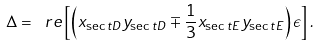Convert formula to latex. <formula><loc_0><loc_0><loc_500><loc_500>\Delta = \ r e \left [ \left ( x _ { \sec t { D } } y _ { \sec t { D } } \mp \frac { 1 } { 3 } x _ { \sec t { E } } y _ { \sec t { E } } \right ) \epsilon \right ] .</formula> 